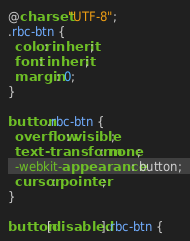Convert code to text. <code><loc_0><loc_0><loc_500><loc_500><_CSS_>@charset "UTF-8";
.rbc-btn {
  color: inherit;
  font: inherit;
  margin: 0;
}

button.rbc-btn {
  overflow: visible;
  text-transform: none;
  -webkit-appearance: button;
  cursor: pointer;
}

button[disabled].rbc-btn {</code> 